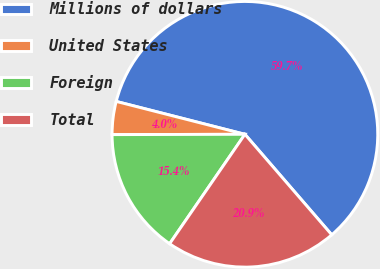Convert chart to OTSL. <chart><loc_0><loc_0><loc_500><loc_500><pie_chart><fcel>Millions of dollars<fcel>United States<fcel>Foreign<fcel>Total<nl><fcel>59.68%<fcel>4.02%<fcel>15.37%<fcel>20.93%<nl></chart> 